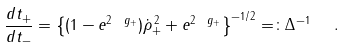<formula> <loc_0><loc_0><loc_500><loc_500>\frac { d t _ { + } } { d t _ { - } } = \left \{ ( 1 - e ^ { 2 \ g _ { + } } ) \dot { \rho } _ { + } ^ { \, 2 } + e ^ { 2 \ g _ { + } } \right \} ^ { - 1 / 2 } = \colon \Delta ^ { - 1 } \ \ .</formula> 